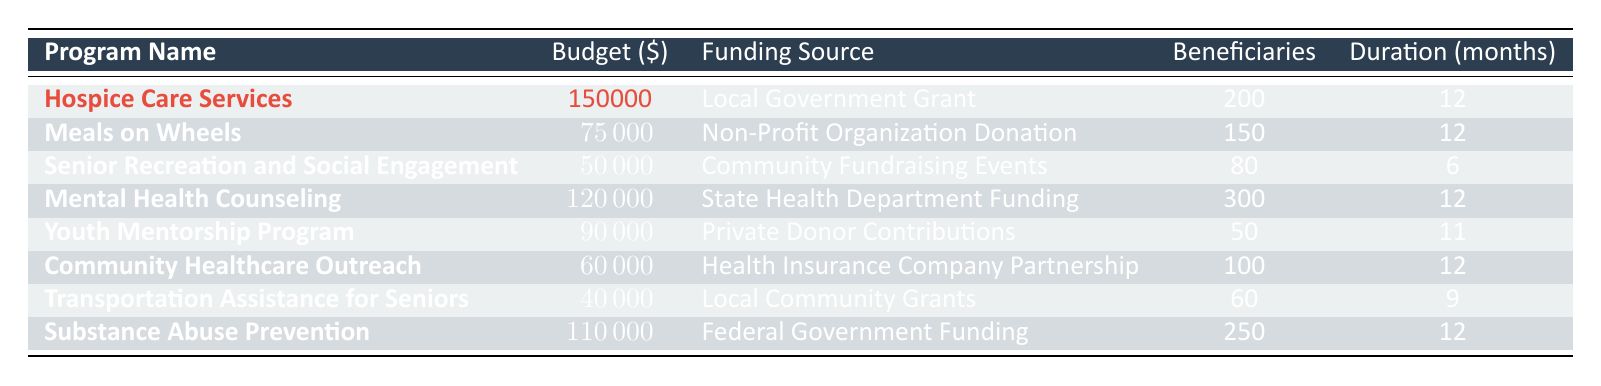What is the allocated budget for Hospice Care Services? The table indicates the allocated budget for Hospice Care Services, which is explicitly listed as 150,000 USD.
Answer: 150000 How many beneficiaries are served by the Youth Mentorship Program? The table shows that the Youth Mentorship Program serves 50 beneficiaries, as this number is directly stated in the program details.
Answer: 50 Which program has the highest allocated budget? By comparing the allocated budgets listed in the table, it is evident that Hospice Care Services has the highest budget at 150,000 USD.
Answer: Hospice Care Services Is the funding for Meals on Wheels sourced from a Non-Profit Organization Donation? The table provides the funding source for Meals on Wheels as "Non-Profit Organization Donation," which directly answers the question.
Answer: Yes How long does the Senior Recreation and Social Engagement program run? The table indicates that the program duration for Senior Recreation and Social Engagement is 6 months, which is clearly stated alongside the program details.
Answer: 6 months What is the total allocated budget for all the programs listed? To find the total budget, we sum all allocated budgets: 150,000 + 75,000 + 50,000 + 120,000 + 90,000 + 60,000 + 40,000 + 110,000 = 695,000 USD.
Answer: 695000 How many beneficiaries are served by programs funded by government sources? The programs with government funding sources are Hospice Care Services (200 beneficiaries), Mental Health Counseling (300 beneficiaries), and Substance Abuse Prevention (250 beneficiaries). Therefore, the total number of beneficiaries served is 200 + 300 + 250 = 750.
Answer: 750 What is the average allocated budget across all programs? To find the average, we first sum all allocated budgets (150,000 + 75,000 + 50,000 + 120,000 + 90,000 + 60,000 + 40,000 + 110,000 = 695,000) and divide by the number of programs (8). Thus, the average allocated budget = 695,000 / 8 = 86,875 USD.
Answer: 86875 Is the Community Healthcare Outreach program the shortest program in terms of duration? The Community Healthcare Outreach program has a duration of 12 months. The shortest duration listed in the table is 6 months for Senior Recreation and Social Engagement, meaning Community Healthcare Outreach is not the shortest.
Answer: No Which funding source supports the highest number of beneficiaries? The program with the highest number of beneficiaries funded is Mental Health Counseling (300 beneficiaries), as shown in the table. This program has the largest number of beneficiaries compared to others.
Answer: State Health Department Funding 